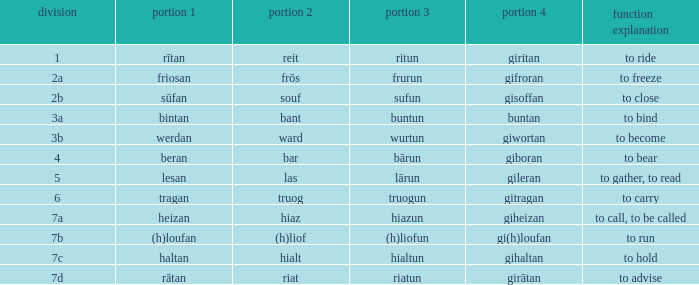What class in the word with part 4 "giheizan"? 7a. 